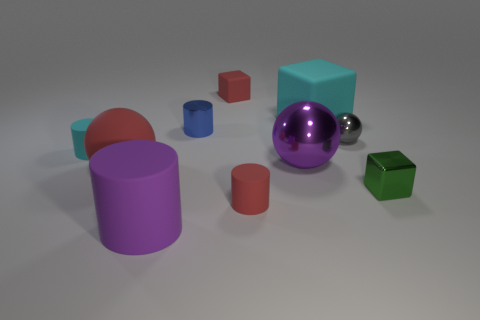How many tiny objects are in front of the purple metal thing and right of the large cyan matte object?
Offer a very short reply. 1. There is a cylinder that is to the left of the purple matte thing; what material is it?
Offer a very short reply. Rubber. What size is the green thing that is the same material as the large purple sphere?
Provide a succinct answer. Small. Is the size of the cyan matte object in front of the small metal sphere the same as the green thing that is on the right side of the big purple shiny thing?
Make the answer very short. Yes. What is the material of the cyan cube that is the same size as the purple matte object?
Your answer should be very brief. Rubber. There is a small cylinder that is both in front of the blue cylinder and right of the large cylinder; what is it made of?
Ensure brevity in your answer.  Rubber. Is there a red rubber object?
Offer a very short reply. Yes. Is the color of the large cube the same as the cube to the right of the large cyan cube?
Give a very brief answer. No. There is a thing that is the same color as the big cube; what material is it?
Give a very brief answer. Rubber. Is there anything else that has the same shape as the tiny cyan object?
Ensure brevity in your answer.  Yes. 